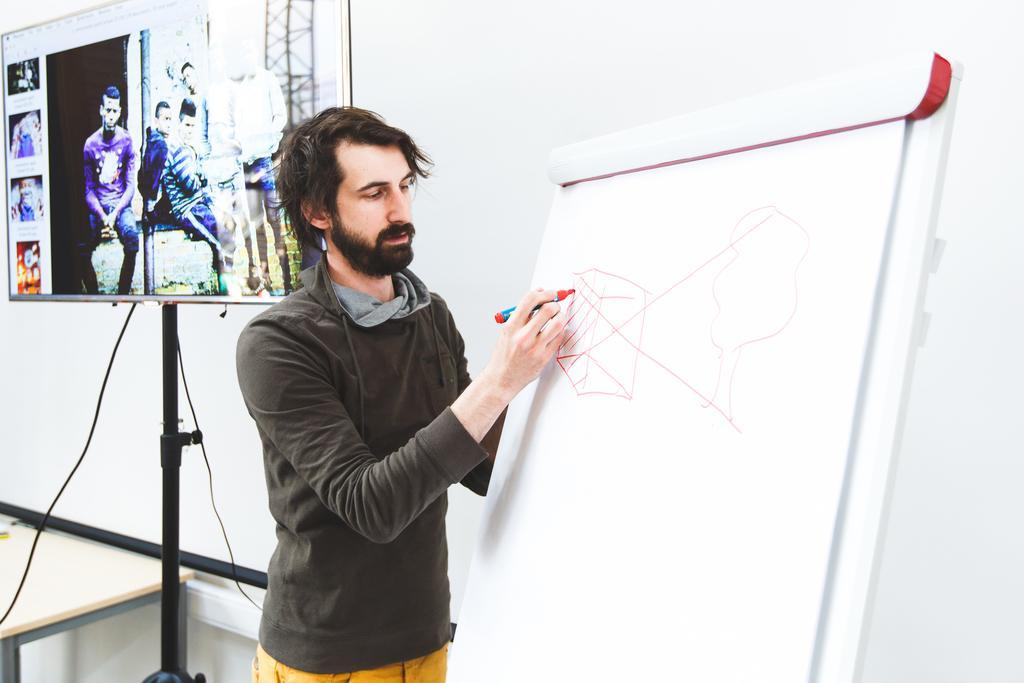How would you summarize this image in a sentence or two? In this image we can see a person standing and holding a pen, in front of him we can see the board with paper. And we can see the screen, in the screen there are people. At the bottom, we can see the table and in the background, we can see the wall. 